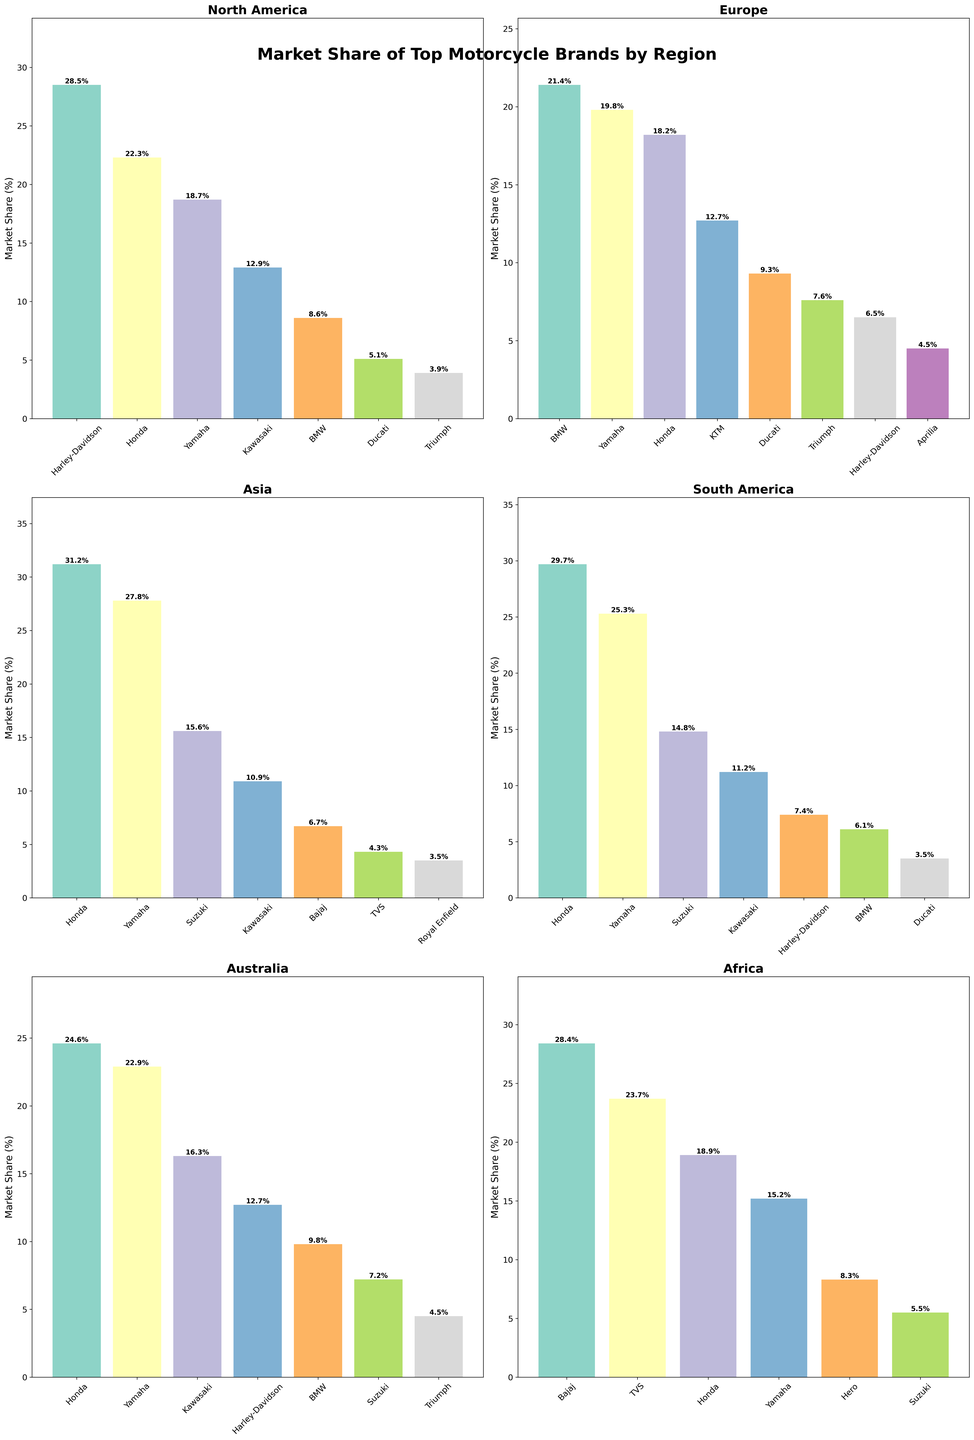Which brand has the highest market share in North America? Look at the bar chart for North America and identify the tallest bar, which represents the highest market share.
Answer: Harley-Davidson Which region does Honda have the lowest market share? Compare the market share of Honda across all regions by looking at the heights of the bars representing Honda in each subplot. Identify the shortest bar.
Answer: Africa What is the total market share of Yamaha in all regions combined? Sum the heights of the bars corresponding to Yamaha in each region: North America (18.7) + Europe (19.8) + Asia (27.8) + South America (25.3) + Australia (22.9) + Africa (15.2).
Answer: 129.7 Which regions have Honda as the top brand? Identify the regions by looking for bars representing Honda that are the tallest in their respective subplots.
Answer: Asia, South America How much greater is the market share of Bajaj in Africa compared to Asia? Subtract Baja's market share in Asia from its market share in Africa: Africa (28.4) - Asia (6.7).
Answer: 21.7 What is the average market share of the top three brands in Europe? Sum the market shares of the top three brands in Europe (BMW, Yamaha, Honda) and divide by three: (21.4 + 19.8 + 18.2) / 3.
Answer: 19.8 Does BMW have higher market share in Europe or North America? Compare the heights of the bars representing BMW in North America and Europe.
Answer: Europe Among all the regions displayed, which brand shows up most frequently? Count the number of occurrences of each brand across all subplots.
Answer: Honda Which brand has a substantially higher market share in one region compared to others? Identify a brand whose bar in one region is significantly taller than its bars in other regions.
Answer: Bajaj in Africa How much combined market share do Ducati and Triumph have in North America? Add the market shares of Ducati and Triumph in North America: 5.1 + 3.9.
Answer: 9.0 